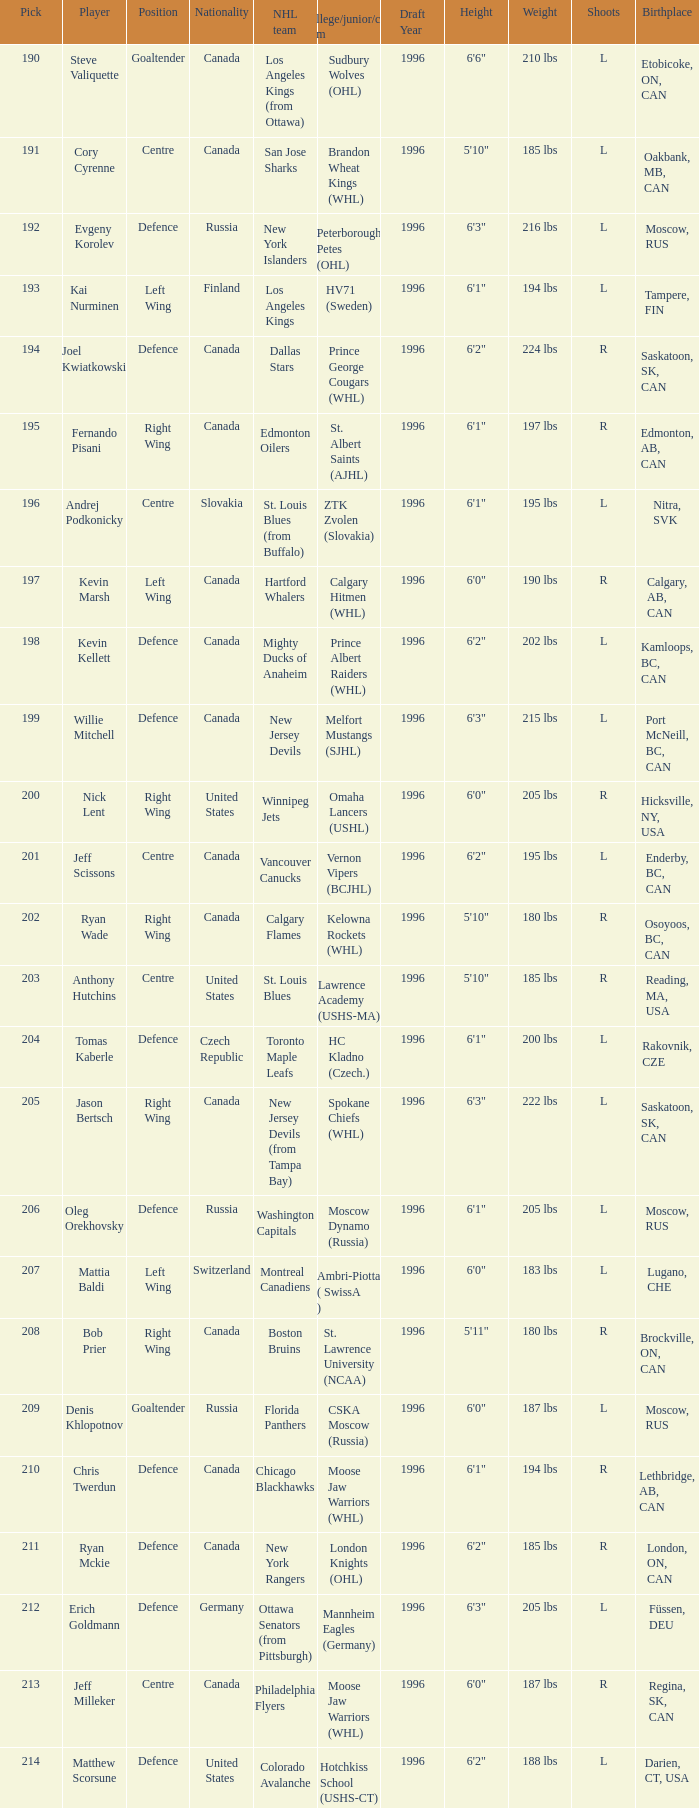Name the most pick for evgeny korolev 192.0. 